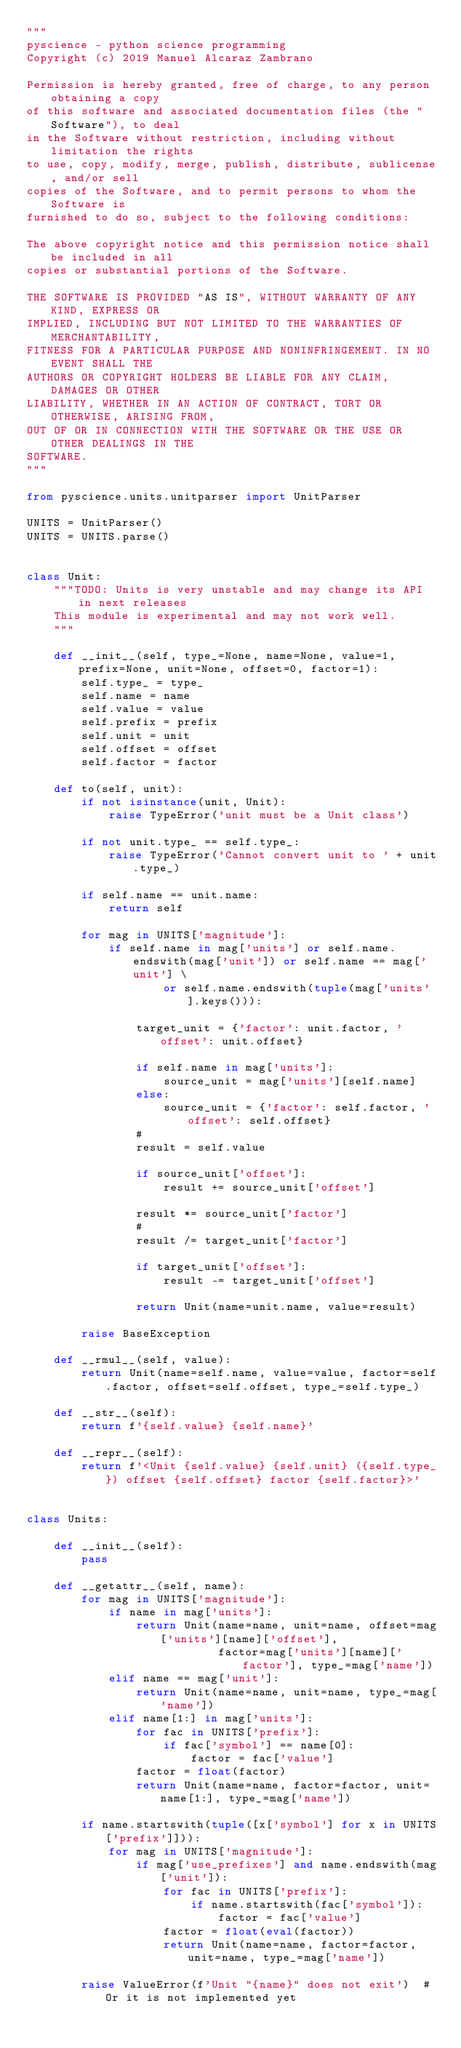Convert code to text. <code><loc_0><loc_0><loc_500><loc_500><_Python_>"""
pyscience - python science programming
Copyright (c) 2019 Manuel Alcaraz Zambrano

Permission is hereby granted, free of charge, to any person obtaining a copy
of this software and associated documentation files (the "Software"), to deal
in the Software without restriction, including without limitation the rights
to use, copy, modify, merge, publish, distribute, sublicense, and/or sell
copies of the Software, and to permit persons to whom the Software is
furnished to do so, subject to the following conditions:

The above copyright notice and this permission notice shall be included in all
copies or substantial portions of the Software.

THE SOFTWARE IS PROVIDED "AS IS", WITHOUT WARRANTY OF ANY KIND, EXPRESS OR
IMPLIED, INCLUDING BUT NOT LIMITED TO THE WARRANTIES OF MERCHANTABILITY,
FITNESS FOR A PARTICULAR PURPOSE AND NONINFRINGEMENT. IN NO EVENT SHALL THE
AUTHORS OR COPYRIGHT HOLDERS BE LIABLE FOR ANY CLAIM, DAMAGES OR OTHER
LIABILITY, WHETHER IN AN ACTION OF CONTRACT, TORT OR OTHERWISE, ARISING FROM,
OUT OF OR IN CONNECTION WITH THE SOFTWARE OR THE USE OR OTHER DEALINGS IN THE
SOFTWARE.
"""

from pyscience.units.unitparser import UnitParser

UNITS = UnitParser()
UNITS = UNITS.parse()


class Unit:
    """TODO: Units is very unstable and may change its API in next releases
    This module is experimental and may not work well.
    """

    def __init__(self, type_=None, name=None, value=1, prefix=None, unit=None, offset=0, factor=1):
        self.type_ = type_
        self.name = name
        self.value = value
        self.prefix = prefix
        self.unit = unit
        self.offset = offset
        self.factor = factor

    def to(self, unit):
        if not isinstance(unit, Unit):
            raise TypeError('unit must be a Unit class')

        if not unit.type_ == self.type_:
            raise TypeError('Cannot convert unit to ' + unit.type_)

        if self.name == unit.name:
            return self

        for mag in UNITS['magnitude']:
            if self.name in mag['units'] or self.name.endswith(mag['unit']) or self.name == mag['unit'] \
                    or self.name.endswith(tuple(mag['units'].keys())):

                target_unit = {'factor': unit.factor, 'offset': unit.offset}

                if self.name in mag['units']:
                    source_unit = mag['units'][self.name]
                else:
                    source_unit = {'factor': self.factor, 'offset': self.offset}
                #
                result = self.value

                if source_unit['offset']:
                    result += source_unit['offset']

                result *= source_unit['factor']
                #
                result /= target_unit['factor']

                if target_unit['offset']:
                    result -= target_unit['offset']

                return Unit(name=unit.name, value=result)

        raise BaseException

    def __rmul__(self, value):
        return Unit(name=self.name, value=value, factor=self.factor, offset=self.offset, type_=self.type_)

    def __str__(self):
        return f'{self.value} {self.name}'

    def __repr__(self):
        return f'<Unit {self.value} {self.unit} ({self.type_}) offset {self.offset} factor {self.factor}>'


class Units:

    def __init__(self):
        pass

    def __getattr__(self, name):
        for mag in UNITS['magnitude']:
            if name in mag['units']:
                return Unit(name=name, unit=name, offset=mag['units'][name]['offset'],
                            factor=mag['units'][name]['factor'], type_=mag['name'])
            elif name == mag['unit']:
                return Unit(name=name, unit=name, type_=mag['name'])
            elif name[1:] in mag['units']:
                for fac in UNITS['prefix']:
                    if fac['symbol'] == name[0]:
                        factor = fac['value']
                factor = float(factor)
                return Unit(name=name, factor=factor, unit=name[1:], type_=mag['name'])

        if name.startswith(tuple([x['symbol'] for x in UNITS['prefix']])):
            for mag in UNITS['magnitude']:
                if mag['use_prefixes'] and name.endswith(mag['unit']):
                    for fac in UNITS['prefix']:
                        if name.startswith(fac['symbol']):
                            factor = fac['value']
                    factor = float(eval(factor))
                    return Unit(name=name, factor=factor, unit=name, type_=mag['name'])

        raise ValueError(f'Unit "{name}" does not exit')  # Or it is not implemented yet
</code> 